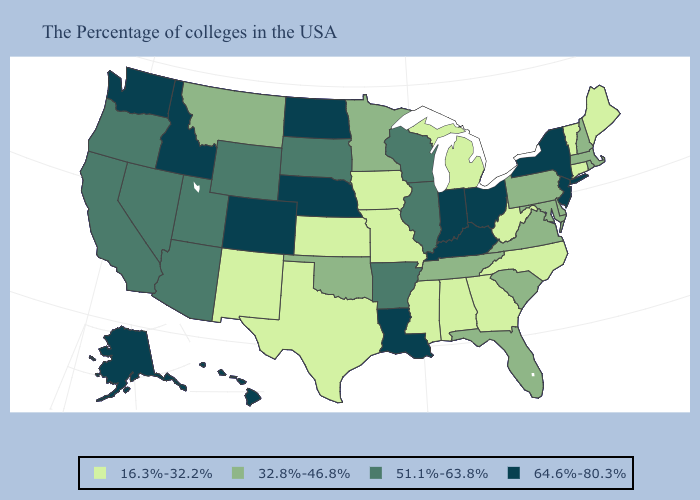Name the states that have a value in the range 51.1%-63.8%?
Short answer required. Wisconsin, Illinois, Arkansas, South Dakota, Wyoming, Utah, Arizona, Nevada, California, Oregon. Does the first symbol in the legend represent the smallest category?
Give a very brief answer. Yes. Name the states that have a value in the range 16.3%-32.2%?
Quick response, please. Maine, Vermont, Connecticut, North Carolina, West Virginia, Georgia, Michigan, Alabama, Mississippi, Missouri, Iowa, Kansas, Texas, New Mexico. Does California have the same value as Massachusetts?
Quick response, please. No. Name the states that have a value in the range 16.3%-32.2%?
Concise answer only. Maine, Vermont, Connecticut, North Carolina, West Virginia, Georgia, Michigan, Alabama, Mississippi, Missouri, Iowa, Kansas, Texas, New Mexico. How many symbols are there in the legend?
Keep it brief. 4. What is the value of Oregon?
Be succinct. 51.1%-63.8%. Name the states that have a value in the range 64.6%-80.3%?
Short answer required. New York, New Jersey, Ohio, Kentucky, Indiana, Louisiana, Nebraska, North Dakota, Colorado, Idaho, Washington, Alaska, Hawaii. Name the states that have a value in the range 64.6%-80.3%?
Give a very brief answer. New York, New Jersey, Ohio, Kentucky, Indiana, Louisiana, Nebraska, North Dakota, Colorado, Idaho, Washington, Alaska, Hawaii. Name the states that have a value in the range 32.8%-46.8%?
Give a very brief answer. Massachusetts, Rhode Island, New Hampshire, Delaware, Maryland, Pennsylvania, Virginia, South Carolina, Florida, Tennessee, Minnesota, Oklahoma, Montana. Among the states that border North Dakota , does Montana have the highest value?
Answer briefly. No. Among the states that border West Virginia , does Pennsylvania have the highest value?
Quick response, please. No. What is the value of Colorado?
Give a very brief answer. 64.6%-80.3%. What is the highest value in states that border Connecticut?
Be succinct. 64.6%-80.3%. Name the states that have a value in the range 51.1%-63.8%?
Short answer required. Wisconsin, Illinois, Arkansas, South Dakota, Wyoming, Utah, Arizona, Nevada, California, Oregon. 